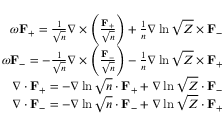Convert formula to latex. <formula><loc_0><loc_0><loc_500><loc_500>\begin{array} { r } { \omega F _ { + } = \frac { 1 } { \sqrt { n } } \nabla \times \left ( \frac { F _ { + } } { \sqrt { n } } \right ) + \frac { 1 } { n } \nabla \ln \sqrt { Z } \times F _ { - } } \\ { \omega F _ { - } = - \frac { 1 } { \sqrt { n } } \nabla \times \left ( \frac { F _ { - } } { \sqrt { n } } \right ) - \frac { 1 } { n } \nabla \ln \sqrt { Z } \times F _ { + } } \\ { \nabla \cdot F _ { + } = - \nabla \ln \sqrt { n } \cdot F _ { + } + \nabla \ln \sqrt { Z } \cdot F _ { - } } \\ { \nabla \cdot F _ { - } = - \nabla \ln \sqrt { n } \cdot F _ { - } + \nabla \ln \sqrt { Z } \cdot F _ { + } } \end{array}</formula> 